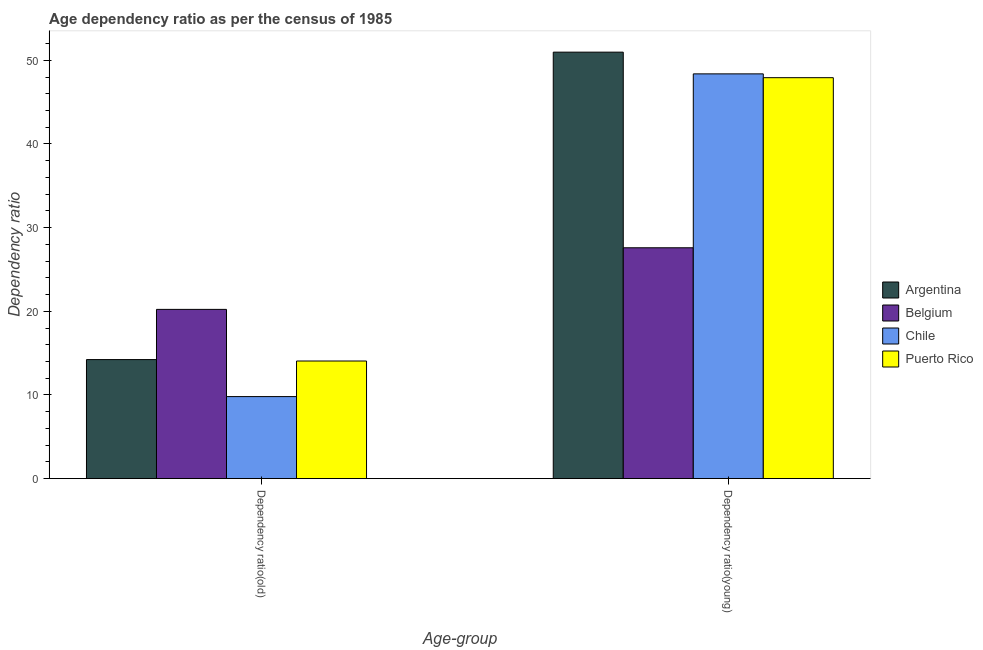How many groups of bars are there?
Your answer should be compact. 2. Are the number of bars per tick equal to the number of legend labels?
Offer a terse response. Yes. Are the number of bars on each tick of the X-axis equal?
Provide a succinct answer. Yes. What is the label of the 1st group of bars from the left?
Provide a short and direct response. Dependency ratio(old). What is the age dependency ratio(young) in Belgium?
Give a very brief answer. 27.59. Across all countries, what is the maximum age dependency ratio(old)?
Your answer should be very brief. 20.23. Across all countries, what is the minimum age dependency ratio(young)?
Your response must be concise. 27.59. In which country was the age dependency ratio(old) minimum?
Offer a very short reply. Chile. What is the total age dependency ratio(old) in the graph?
Offer a very short reply. 58.31. What is the difference between the age dependency ratio(old) in Argentina and that in Belgium?
Ensure brevity in your answer.  -6. What is the difference between the age dependency ratio(old) in Chile and the age dependency ratio(young) in Puerto Rico?
Provide a succinct answer. -38.12. What is the average age dependency ratio(young) per country?
Your answer should be compact. 43.72. What is the difference between the age dependency ratio(old) and age dependency ratio(young) in Puerto Rico?
Keep it short and to the point. -33.87. In how many countries, is the age dependency ratio(young) greater than 36 ?
Offer a terse response. 3. What is the ratio of the age dependency ratio(young) in Puerto Rico to that in Argentina?
Your answer should be compact. 0.94. In how many countries, is the age dependency ratio(young) greater than the average age dependency ratio(young) taken over all countries?
Make the answer very short. 3. What does the 4th bar from the right in Dependency ratio(young) represents?
Give a very brief answer. Argentina. How many bars are there?
Provide a short and direct response. 8. Are all the bars in the graph horizontal?
Offer a terse response. No. What is the difference between two consecutive major ticks on the Y-axis?
Provide a short and direct response. 10. Does the graph contain any zero values?
Offer a very short reply. No. What is the title of the graph?
Keep it short and to the point. Age dependency ratio as per the census of 1985. Does "Solomon Islands" appear as one of the legend labels in the graph?
Make the answer very short. No. What is the label or title of the X-axis?
Provide a short and direct response. Age-group. What is the label or title of the Y-axis?
Your response must be concise. Dependency ratio. What is the Dependency ratio in Argentina in Dependency ratio(old)?
Your response must be concise. 14.23. What is the Dependency ratio of Belgium in Dependency ratio(old)?
Your response must be concise. 20.23. What is the Dependency ratio in Chile in Dependency ratio(old)?
Provide a short and direct response. 9.8. What is the Dependency ratio in Puerto Rico in Dependency ratio(old)?
Provide a short and direct response. 14.06. What is the Dependency ratio of Argentina in Dependency ratio(young)?
Make the answer very short. 50.97. What is the Dependency ratio of Belgium in Dependency ratio(young)?
Provide a succinct answer. 27.59. What is the Dependency ratio of Chile in Dependency ratio(young)?
Keep it short and to the point. 48.38. What is the Dependency ratio in Puerto Rico in Dependency ratio(young)?
Make the answer very short. 47.92. Across all Age-group, what is the maximum Dependency ratio in Argentina?
Ensure brevity in your answer.  50.97. Across all Age-group, what is the maximum Dependency ratio of Belgium?
Offer a very short reply. 27.59. Across all Age-group, what is the maximum Dependency ratio of Chile?
Give a very brief answer. 48.38. Across all Age-group, what is the maximum Dependency ratio in Puerto Rico?
Your answer should be very brief. 47.92. Across all Age-group, what is the minimum Dependency ratio in Argentina?
Offer a very short reply. 14.23. Across all Age-group, what is the minimum Dependency ratio in Belgium?
Offer a very short reply. 20.23. Across all Age-group, what is the minimum Dependency ratio of Chile?
Provide a succinct answer. 9.8. Across all Age-group, what is the minimum Dependency ratio of Puerto Rico?
Provide a succinct answer. 14.06. What is the total Dependency ratio in Argentina in the graph?
Your answer should be very brief. 65.2. What is the total Dependency ratio in Belgium in the graph?
Your answer should be very brief. 47.82. What is the total Dependency ratio of Chile in the graph?
Your answer should be compact. 58.18. What is the total Dependency ratio in Puerto Rico in the graph?
Keep it short and to the point. 61.98. What is the difference between the Dependency ratio of Argentina in Dependency ratio(old) and that in Dependency ratio(young)?
Provide a short and direct response. -36.75. What is the difference between the Dependency ratio of Belgium in Dependency ratio(old) and that in Dependency ratio(young)?
Offer a very short reply. -7.36. What is the difference between the Dependency ratio of Chile in Dependency ratio(old) and that in Dependency ratio(young)?
Keep it short and to the point. -38.57. What is the difference between the Dependency ratio of Puerto Rico in Dependency ratio(old) and that in Dependency ratio(young)?
Keep it short and to the point. -33.87. What is the difference between the Dependency ratio of Argentina in Dependency ratio(old) and the Dependency ratio of Belgium in Dependency ratio(young)?
Offer a very short reply. -13.37. What is the difference between the Dependency ratio in Argentina in Dependency ratio(old) and the Dependency ratio in Chile in Dependency ratio(young)?
Your answer should be compact. -34.15. What is the difference between the Dependency ratio of Argentina in Dependency ratio(old) and the Dependency ratio of Puerto Rico in Dependency ratio(young)?
Offer a terse response. -33.7. What is the difference between the Dependency ratio in Belgium in Dependency ratio(old) and the Dependency ratio in Chile in Dependency ratio(young)?
Give a very brief answer. -28.15. What is the difference between the Dependency ratio of Belgium in Dependency ratio(old) and the Dependency ratio of Puerto Rico in Dependency ratio(young)?
Give a very brief answer. -27.7. What is the difference between the Dependency ratio of Chile in Dependency ratio(old) and the Dependency ratio of Puerto Rico in Dependency ratio(young)?
Provide a succinct answer. -38.12. What is the average Dependency ratio of Argentina per Age-group?
Offer a very short reply. 32.6. What is the average Dependency ratio in Belgium per Age-group?
Keep it short and to the point. 23.91. What is the average Dependency ratio of Chile per Age-group?
Provide a succinct answer. 29.09. What is the average Dependency ratio of Puerto Rico per Age-group?
Provide a succinct answer. 30.99. What is the difference between the Dependency ratio of Argentina and Dependency ratio of Belgium in Dependency ratio(old)?
Keep it short and to the point. -6. What is the difference between the Dependency ratio of Argentina and Dependency ratio of Chile in Dependency ratio(old)?
Offer a terse response. 4.42. What is the difference between the Dependency ratio of Argentina and Dependency ratio of Puerto Rico in Dependency ratio(old)?
Your response must be concise. 0.17. What is the difference between the Dependency ratio of Belgium and Dependency ratio of Chile in Dependency ratio(old)?
Provide a succinct answer. 10.42. What is the difference between the Dependency ratio in Belgium and Dependency ratio in Puerto Rico in Dependency ratio(old)?
Your answer should be very brief. 6.17. What is the difference between the Dependency ratio of Chile and Dependency ratio of Puerto Rico in Dependency ratio(old)?
Ensure brevity in your answer.  -4.25. What is the difference between the Dependency ratio of Argentina and Dependency ratio of Belgium in Dependency ratio(young)?
Offer a very short reply. 23.38. What is the difference between the Dependency ratio in Argentina and Dependency ratio in Chile in Dependency ratio(young)?
Give a very brief answer. 2.6. What is the difference between the Dependency ratio in Argentina and Dependency ratio in Puerto Rico in Dependency ratio(young)?
Ensure brevity in your answer.  3.05. What is the difference between the Dependency ratio in Belgium and Dependency ratio in Chile in Dependency ratio(young)?
Offer a very short reply. -20.79. What is the difference between the Dependency ratio in Belgium and Dependency ratio in Puerto Rico in Dependency ratio(young)?
Ensure brevity in your answer.  -20.33. What is the difference between the Dependency ratio in Chile and Dependency ratio in Puerto Rico in Dependency ratio(young)?
Provide a succinct answer. 0.46. What is the ratio of the Dependency ratio in Argentina in Dependency ratio(old) to that in Dependency ratio(young)?
Your response must be concise. 0.28. What is the ratio of the Dependency ratio of Belgium in Dependency ratio(old) to that in Dependency ratio(young)?
Ensure brevity in your answer.  0.73. What is the ratio of the Dependency ratio of Chile in Dependency ratio(old) to that in Dependency ratio(young)?
Provide a succinct answer. 0.2. What is the ratio of the Dependency ratio of Puerto Rico in Dependency ratio(old) to that in Dependency ratio(young)?
Provide a short and direct response. 0.29. What is the difference between the highest and the second highest Dependency ratio of Argentina?
Your answer should be very brief. 36.75. What is the difference between the highest and the second highest Dependency ratio in Belgium?
Give a very brief answer. 7.36. What is the difference between the highest and the second highest Dependency ratio of Chile?
Offer a terse response. 38.57. What is the difference between the highest and the second highest Dependency ratio of Puerto Rico?
Provide a short and direct response. 33.87. What is the difference between the highest and the lowest Dependency ratio in Argentina?
Offer a very short reply. 36.75. What is the difference between the highest and the lowest Dependency ratio in Belgium?
Offer a very short reply. 7.36. What is the difference between the highest and the lowest Dependency ratio in Chile?
Offer a terse response. 38.57. What is the difference between the highest and the lowest Dependency ratio of Puerto Rico?
Your answer should be compact. 33.87. 